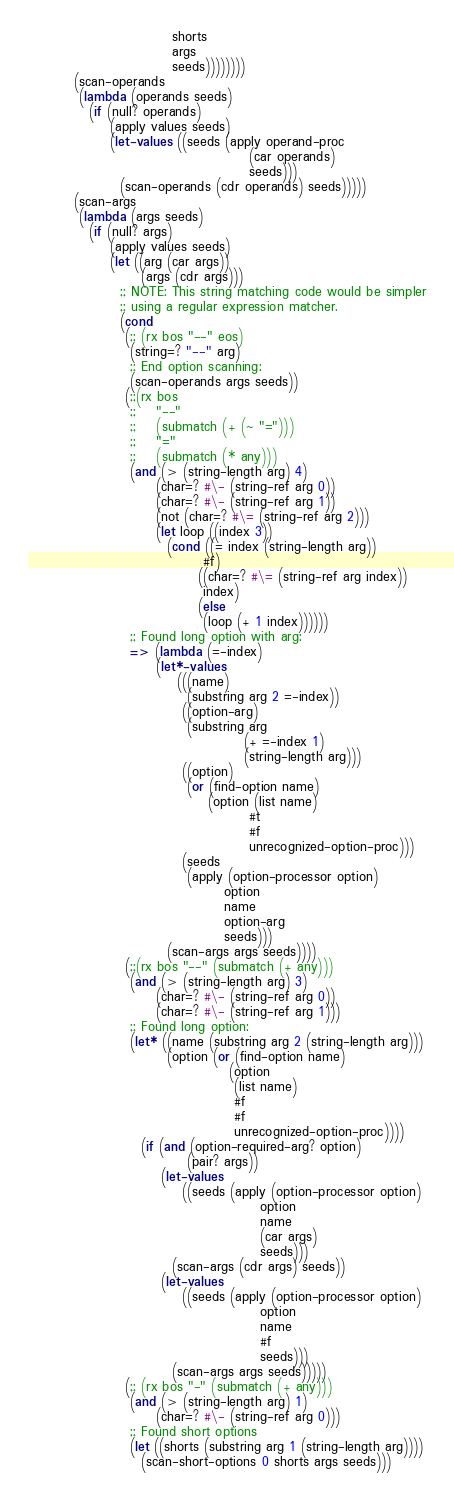Convert code to text. <code><loc_0><loc_0><loc_500><loc_500><_Scheme_>                            shorts
                            args
                            seeds))))))))
         (scan-operands
          (lambda (operands seeds)
            (if (null? operands)
                (apply values seeds)
                (let-values ((seeds (apply operand-proc
                                           (car operands)
                                           seeds)))
                  (scan-operands (cdr operands) seeds)))))
         (scan-args
          (lambda (args seeds)
            (if (null? args)
                (apply values seeds)
                (let ((arg (car args))
                      (args (cdr args)))
                  ;; NOTE: This string matching code would be simpler
                  ;; using a regular expression matcher.
                  (cond
                   (;; (rx bos "--" eos)
                    (string=? "--" arg)
                    ;; End option scanning:
                    (scan-operands args seeds))
                   (;;(rx bos
                    ;;    "--"
                    ;;    (submatch (+ (~ "=")))
                    ;;    "="
                    ;;    (submatch (* any)))
                    (and (> (string-length arg) 4)
                         (char=? #\- (string-ref arg 0))
                         (char=? #\- (string-ref arg 1))
                         (not (char=? #\= (string-ref arg 2)))
                         (let loop ((index 3))
                           (cond ((= index (string-length arg))
                                  #f)
                                 ((char=? #\= (string-ref arg index))
                                  index)
                                 (else
                                  (loop (+ 1 index))))))
                    ;; Found long option with arg:
                    => (lambda (=-index)
                         (let*-values
                             (((name)
                               (substring arg 2 =-index))
                              ((option-arg)
                               (substring arg
                                          (+ =-index 1)
                                          (string-length arg)))
                              ((option)
                               (or (find-option name)
                                   (option (list name)
                                           #t
                                           #f
                                           unrecognized-option-proc)))
                              (seeds
                               (apply (option-processor option)
                                      option
                                      name
                                      option-arg
                                      seeds)))
                           (scan-args args seeds))))
                   (;;(rx bos "--" (submatch (+ any)))
                    (and (> (string-length arg) 3)
                         (char=? #\- (string-ref arg 0))
                         (char=? #\- (string-ref arg 1)))
                    ;; Found long option:
                    (let* ((name (substring arg 2 (string-length arg)))
                           (option (or (find-option name)
                                       (option
                                        (list name)
                                        #f
                                        #f
                                        unrecognized-option-proc))))
                      (if (and (option-required-arg? option)
                               (pair? args))
                          (let-values
                              ((seeds (apply (option-processor option)
                                             option
                                             name
                                             (car args)
                                             seeds)))
                            (scan-args (cdr args) seeds))
                          (let-values
                              ((seeds (apply (option-processor option)
                                             option
                                             name
                                             #f
                                             seeds)))
                            (scan-args args seeds)))))
                   (;; (rx bos "-" (submatch (+ any)))
                    (and (> (string-length arg) 1)
                         (char=? #\- (string-ref arg 0)))
                    ;; Found short options
                    (let ((shorts (substring arg 1 (string-length arg))))
                      (scan-short-options 0 shorts args seeds)))</code> 